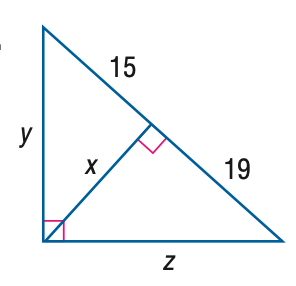Question: Find z.
Choices:
A. \sqrt { 285 }
B. \sqrt { 646 }
C. 2 \sqrt { 285 }
D. 2 \sqrt { 646 }
Answer with the letter. Answer: B Question: Find x.
Choices:
A. 15
B. \sqrt { 285 }
C. 17
D. 2 \sqrt { 285 }
Answer with the letter. Answer: B Question: Find y.
Choices:
A. \sqrt { 285 }
B. \sqrt { 510 }
C. 2 \sqrt { 285 }
D. 2 \sqrt { 510 }
Answer with the letter. Answer: B 